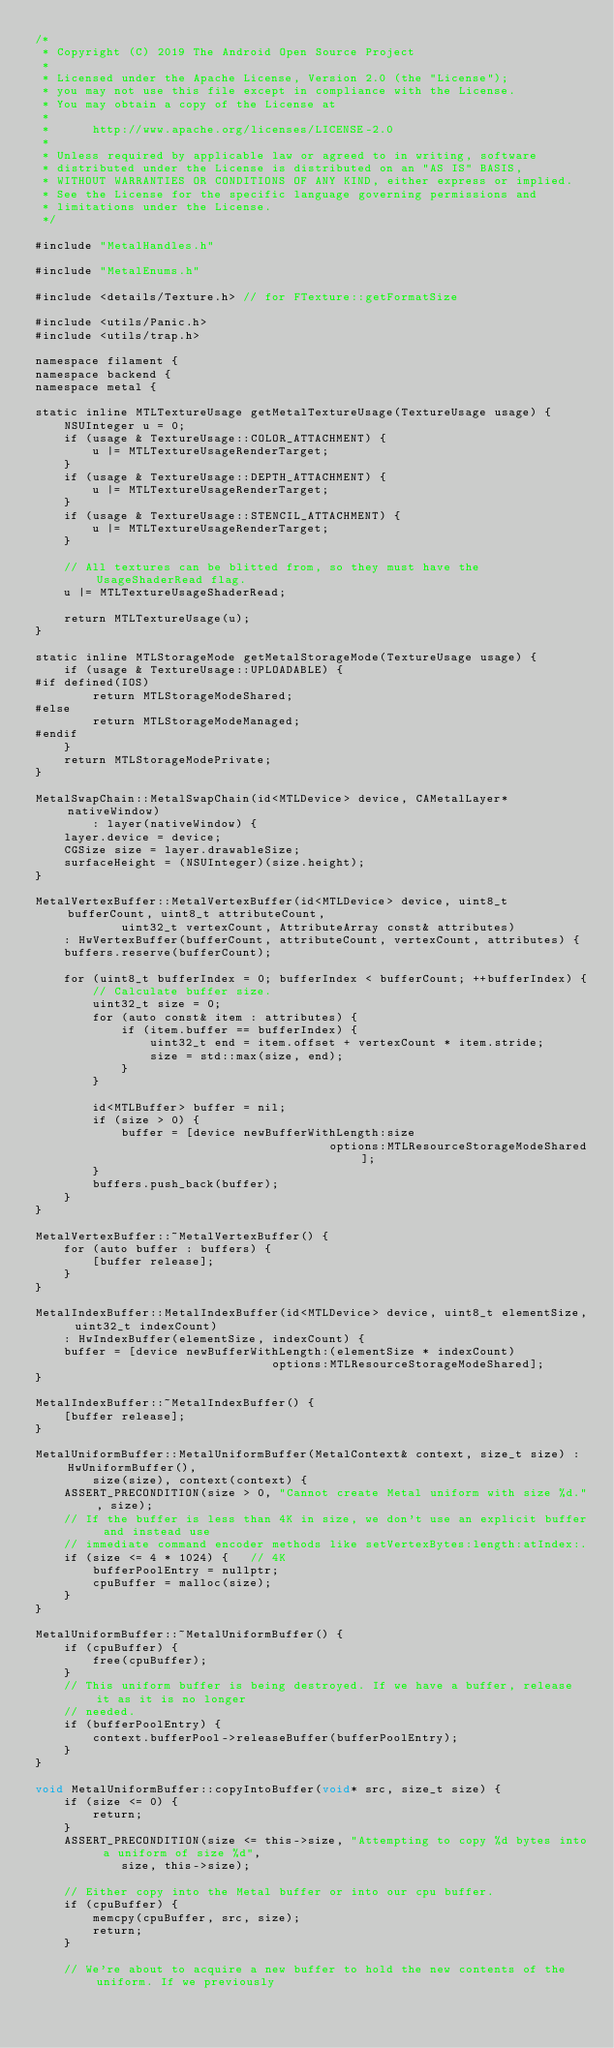<code> <loc_0><loc_0><loc_500><loc_500><_ObjectiveC_>/*
 * Copyright (C) 2019 The Android Open Source Project
 *
 * Licensed under the Apache License, Version 2.0 (the "License");
 * you may not use this file except in compliance with the License.
 * You may obtain a copy of the License at
 *
 *      http://www.apache.org/licenses/LICENSE-2.0
 *
 * Unless required by applicable law or agreed to in writing, software
 * distributed under the License is distributed on an "AS IS" BASIS,
 * WITHOUT WARRANTIES OR CONDITIONS OF ANY KIND, either express or implied.
 * See the License for the specific language governing permissions and
 * limitations under the License.
 */

#include "MetalHandles.h"

#include "MetalEnums.h"

#include <details/Texture.h> // for FTexture::getFormatSize

#include <utils/Panic.h>
#include <utils/trap.h>

namespace filament {
namespace backend {
namespace metal {

static inline MTLTextureUsage getMetalTextureUsage(TextureUsage usage) {
    NSUInteger u = 0;
    if (usage & TextureUsage::COLOR_ATTACHMENT) {
        u |= MTLTextureUsageRenderTarget;
    }
    if (usage & TextureUsage::DEPTH_ATTACHMENT) {
        u |= MTLTextureUsageRenderTarget;
    }
    if (usage & TextureUsage::STENCIL_ATTACHMENT) {
        u |= MTLTextureUsageRenderTarget;
    }

    // All textures can be blitted from, so they must have the UsageShaderRead flag.
    u |= MTLTextureUsageShaderRead;

    return MTLTextureUsage(u);
}

static inline MTLStorageMode getMetalStorageMode(TextureUsage usage) {
    if (usage & TextureUsage::UPLOADABLE) {
#if defined(IOS)
        return MTLStorageModeShared;
#else
        return MTLStorageModeManaged;
#endif
    }
    return MTLStorageModePrivate;
}

MetalSwapChain::MetalSwapChain(id<MTLDevice> device, CAMetalLayer* nativeWindow)
        : layer(nativeWindow) {
    layer.device = device;
    CGSize size = layer.drawableSize;
    surfaceHeight = (NSUInteger)(size.height);
}

MetalVertexBuffer::MetalVertexBuffer(id<MTLDevice> device, uint8_t bufferCount, uint8_t attributeCount,
            uint32_t vertexCount, AttributeArray const& attributes)
    : HwVertexBuffer(bufferCount, attributeCount, vertexCount, attributes) {
    buffers.reserve(bufferCount);

    for (uint8_t bufferIndex = 0; bufferIndex < bufferCount; ++bufferIndex) {
        // Calculate buffer size.
        uint32_t size = 0;
        for (auto const& item : attributes) {
            if (item.buffer == bufferIndex) {
                uint32_t end = item.offset + vertexCount * item.stride;
                size = std::max(size, end);
            }
        }

        id<MTLBuffer> buffer = nil;
        if (size > 0) {
            buffer = [device newBufferWithLength:size
                                         options:MTLResourceStorageModeShared];
        }
        buffers.push_back(buffer);
    }
}

MetalVertexBuffer::~MetalVertexBuffer() {
    for (auto buffer : buffers) {
        [buffer release];
    }
}

MetalIndexBuffer::MetalIndexBuffer(id<MTLDevice> device, uint8_t elementSize, uint32_t indexCount)
    : HwIndexBuffer(elementSize, indexCount) {
    buffer = [device newBufferWithLength:(elementSize * indexCount)
                                 options:MTLResourceStorageModeShared];
}

MetalIndexBuffer::~MetalIndexBuffer() {
    [buffer release];
}

MetalUniformBuffer::MetalUniformBuffer(MetalContext& context, size_t size) : HwUniformBuffer(),
        size(size), context(context) {
    ASSERT_PRECONDITION(size > 0, "Cannot create Metal uniform with size %d.", size);
    // If the buffer is less than 4K in size, we don't use an explicit buffer and instead use
    // immediate command encoder methods like setVertexBytes:length:atIndex:.
    if (size <= 4 * 1024) {   // 4K
        bufferPoolEntry = nullptr;
        cpuBuffer = malloc(size);
    }
}

MetalUniformBuffer::~MetalUniformBuffer() {
    if (cpuBuffer) {
        free(cpuBuffer);
    }
    // This uniform buffer is being destroyed. If we have a buffer, release it as it is no longer
    // needed.
    if (bufferPoolEntry) {
        context.bufferPool->releaseBuffer(bufferPoolEntry);
    }
}

void MetalUniformBuffer::copyIntoBuffer(void* src, size_t size) {
    if (size <= 0) {
        return;
    }
    ASSERT_PRECONDITION(size <= this->size, "Attempting to copy %d bytes into a uniform of size %d",
            size, this->size);

    // Either copy into the Metal buffer or into our cpu buffer.
    if (cpuBuffer) {
        memcpy(cpuBuffer, src, size);
        return;
    }

    // We're about to acquire a new buffer to hold the new contents of the uniform. If we previously</code> 